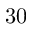<formula> <loc_0><loc_0><loc_500><loc_500>3 0</formula> 